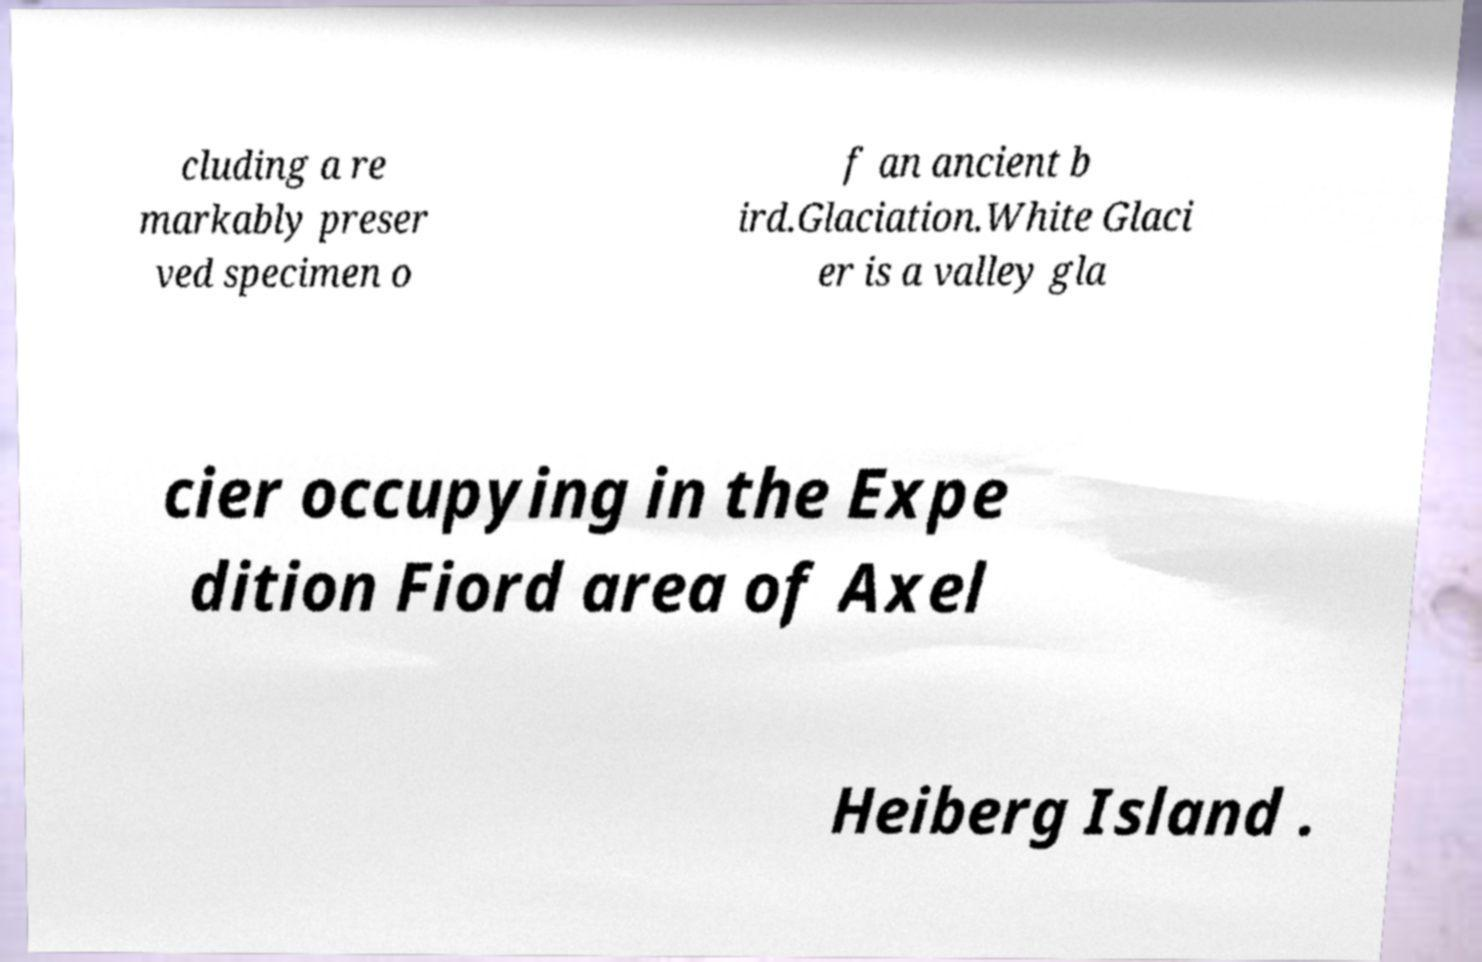There's text embedded in this image that I need extracted. Can you transcribe it verbatim? cluding a re markably preser ved specimen o f an ancient b ird.Glaciation.White Glaci er is a valley gla cier occupying in the Expe dition Fiord area of Axel Heiberg Island . 